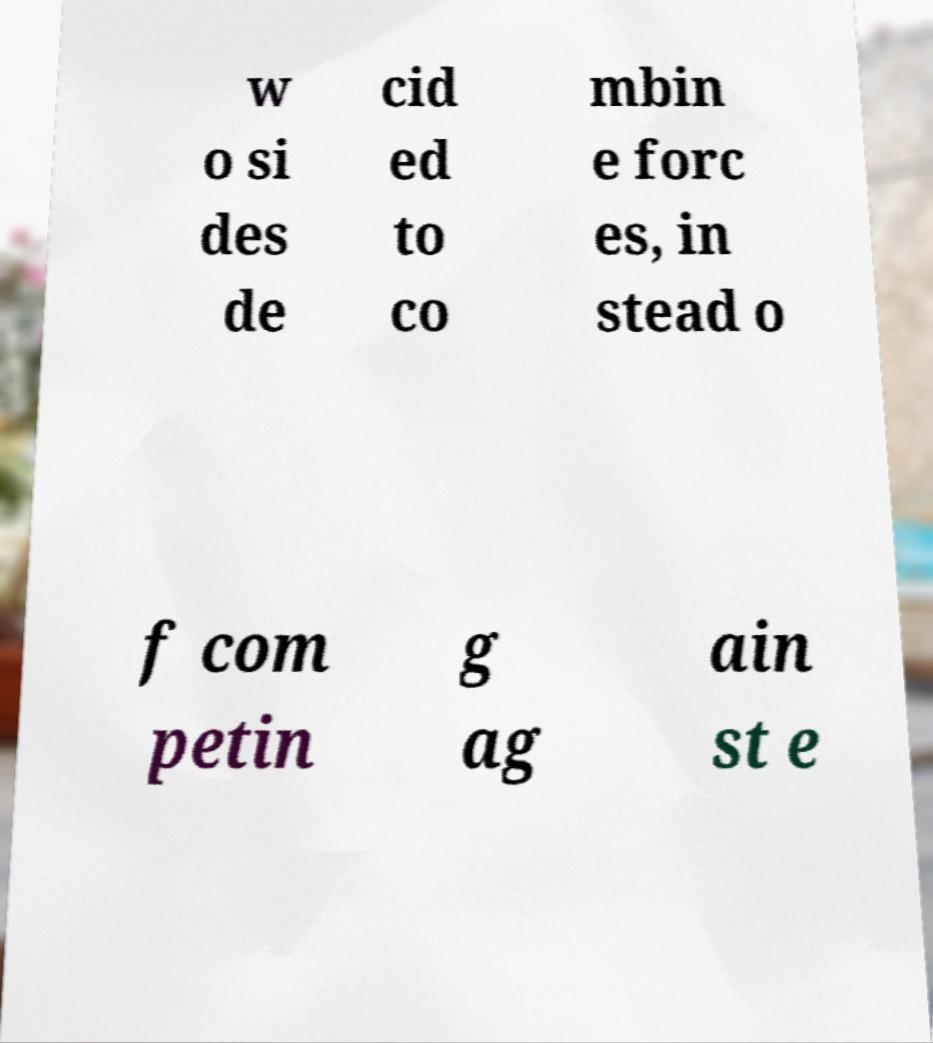Could you assist in decoding the text presented in this image and type it out clearly? w o si des de cid ed to co mbin e forc es, in stead o f com petin g ag ain st e 